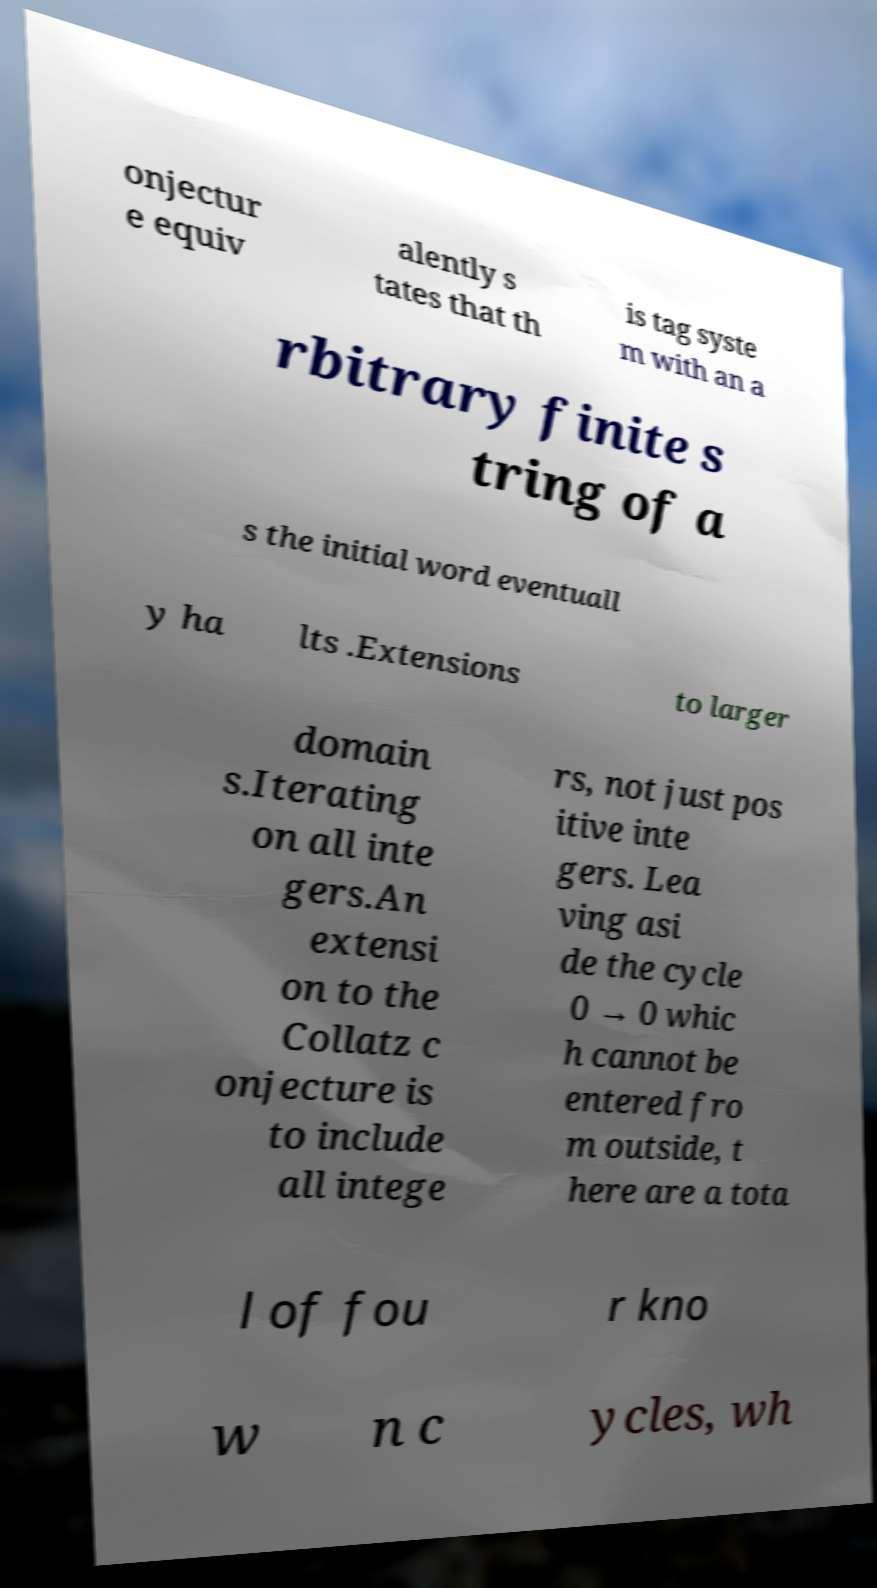I need the written content from this picture converted into text. Can you do that? onjectur e equiv alently s tates that th is tag syste m with an a rbitrary finite s tring of a s the initial word eventuall y ha lts .Extensions to larger domain s.Iterating on all inte gers.An extensi on to the Collatz c onjecture is to include all intege rs, not just pos itive inte gers. Lea ving asi de the cycle 0 → 0 whic h cannot be entered fro m outside, t here are a tota l of fou r kno w n c ycles, wh 